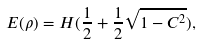<formula> <loc_0><loc_0><loc_500><loc_500>E ( \rho ) = H ( \frac { 1 } { 2 } + \frac { 1 } { 2 } \sqrt { 1 - C ^ { 2 } } ) ,</formula> 